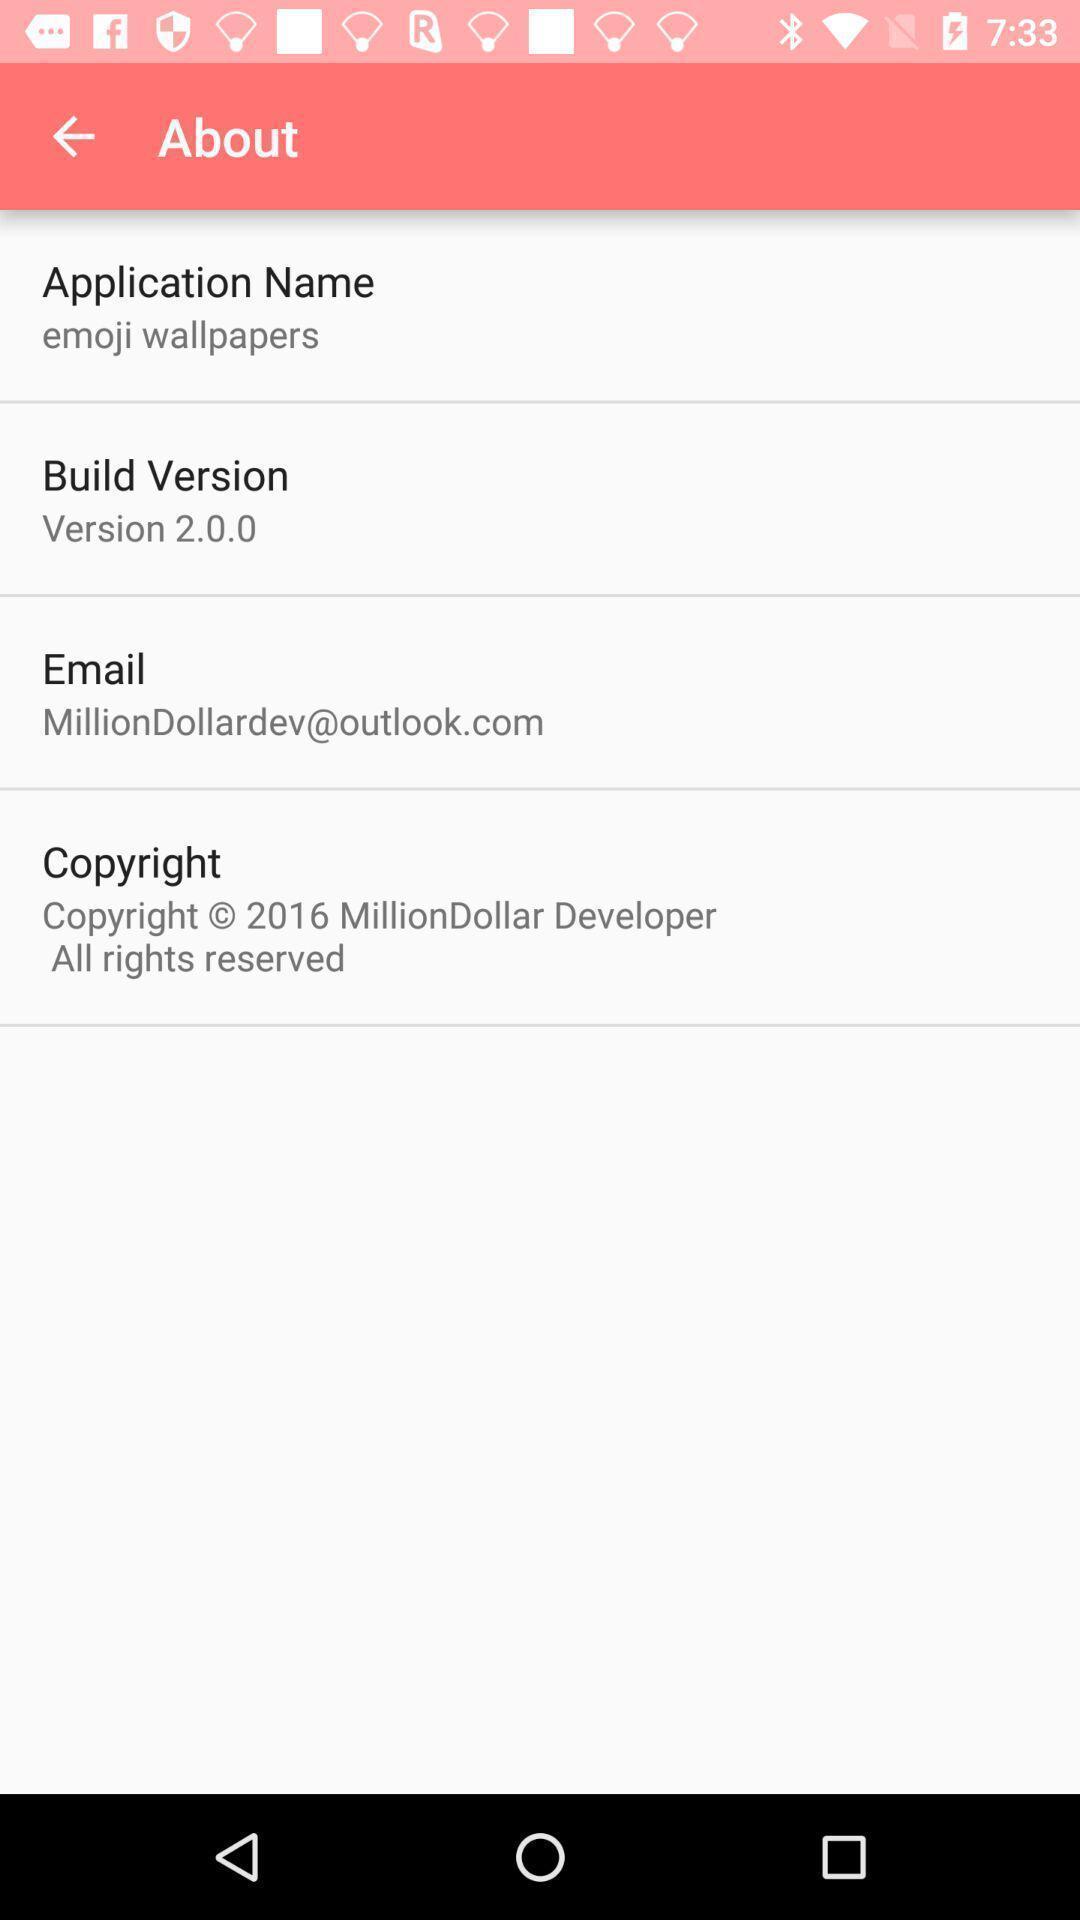Describe the content in this image. Screen shows the details. 